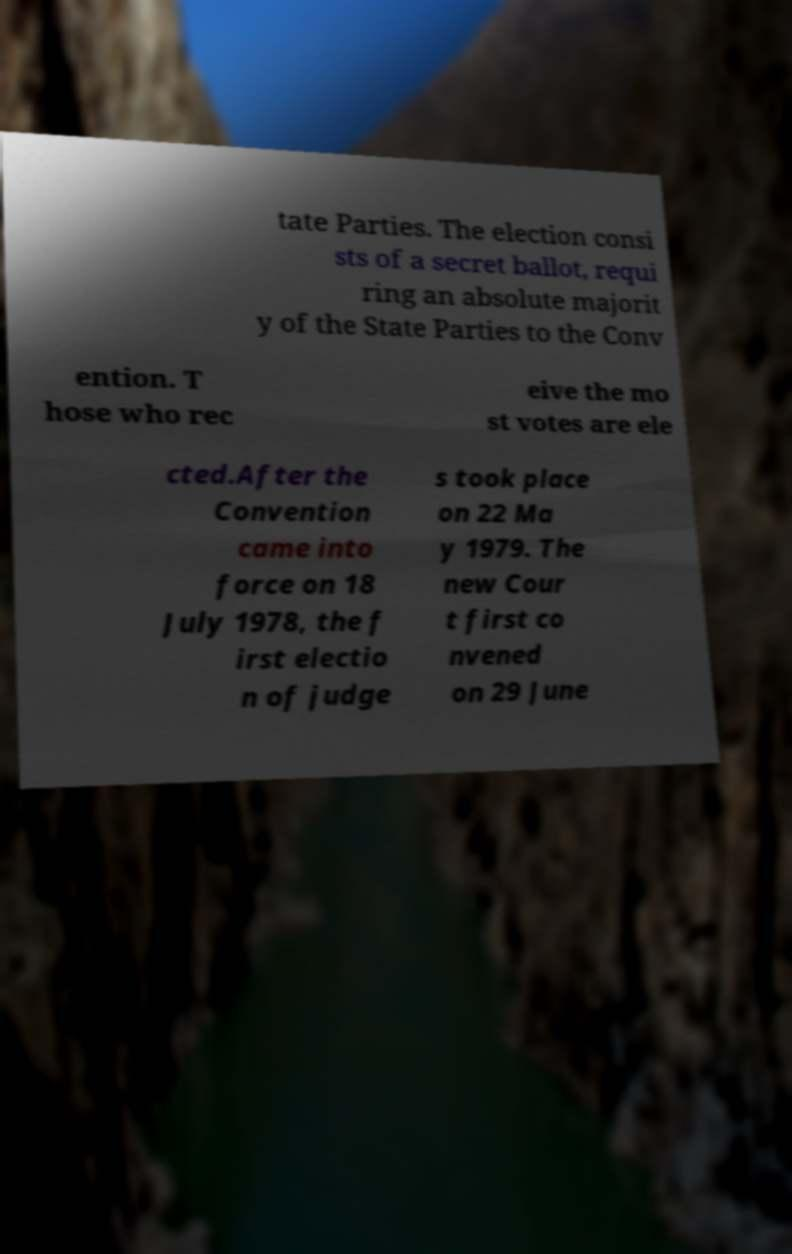For documentation purposes, I need the text within this image transcribed. Could you provide that? tate Parties. The election consi sts of a secret ballot, requi ring an absolute majorit y of the State Parties to the Conv ention. T hose who rec eive the mo st votes are ele cted.After the Convention came into force on 18 July 1978, the f irst electio n of judge s took place on 22 Ma y 1979. The new Cour t first co nvened on 29 June 